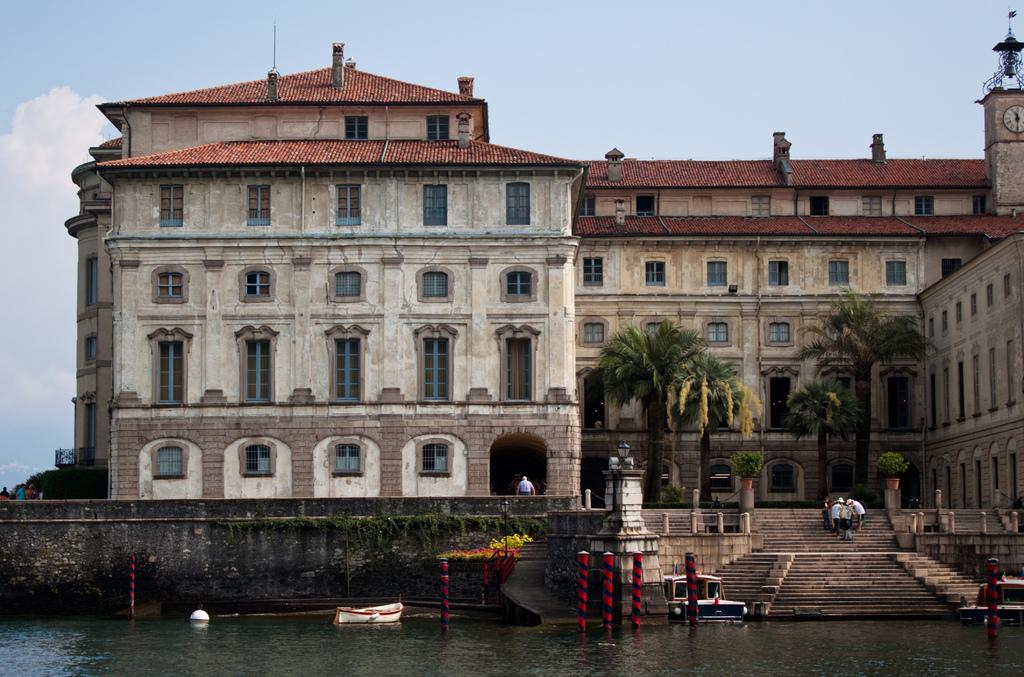What is on the water in the image? There are boats on the water in the image. What objects can be seen in the image besides the boats? There are poles, trees, a building with windows, and persons standing on steps in the image. Can you describe the building in the image? The building has windows. What is visible in the background of the image? The sky with clouds is visible in the background of the image. How many toys are visible in the image? There are no toys present in the image. Can you describe the ladybug on the building in the image? There is no ladybug present on the building or anywhere else in the image. 